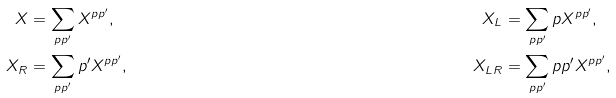Convert formula to latex. <formula><loc_0><loc_0><loc_500><loc_500>X & = \sum _ { p p ^ { \prime } } X ^ { p p ^ { \prime } } , & X _ { L } & = \sum _ { p p ^ { \prime } } p X ^ { p p ^ { \prime } } , \\ X _ { R } & = \sum _ { p p ^ { \prime } } p ^ { \prime } X ^ { p p ^ { \prime } } , & X _ { L R } & = \sum _ { p p ^ { \prime } } p p ^ { \prime } X ^ { p p ^ { \prime } } ,</formula> 